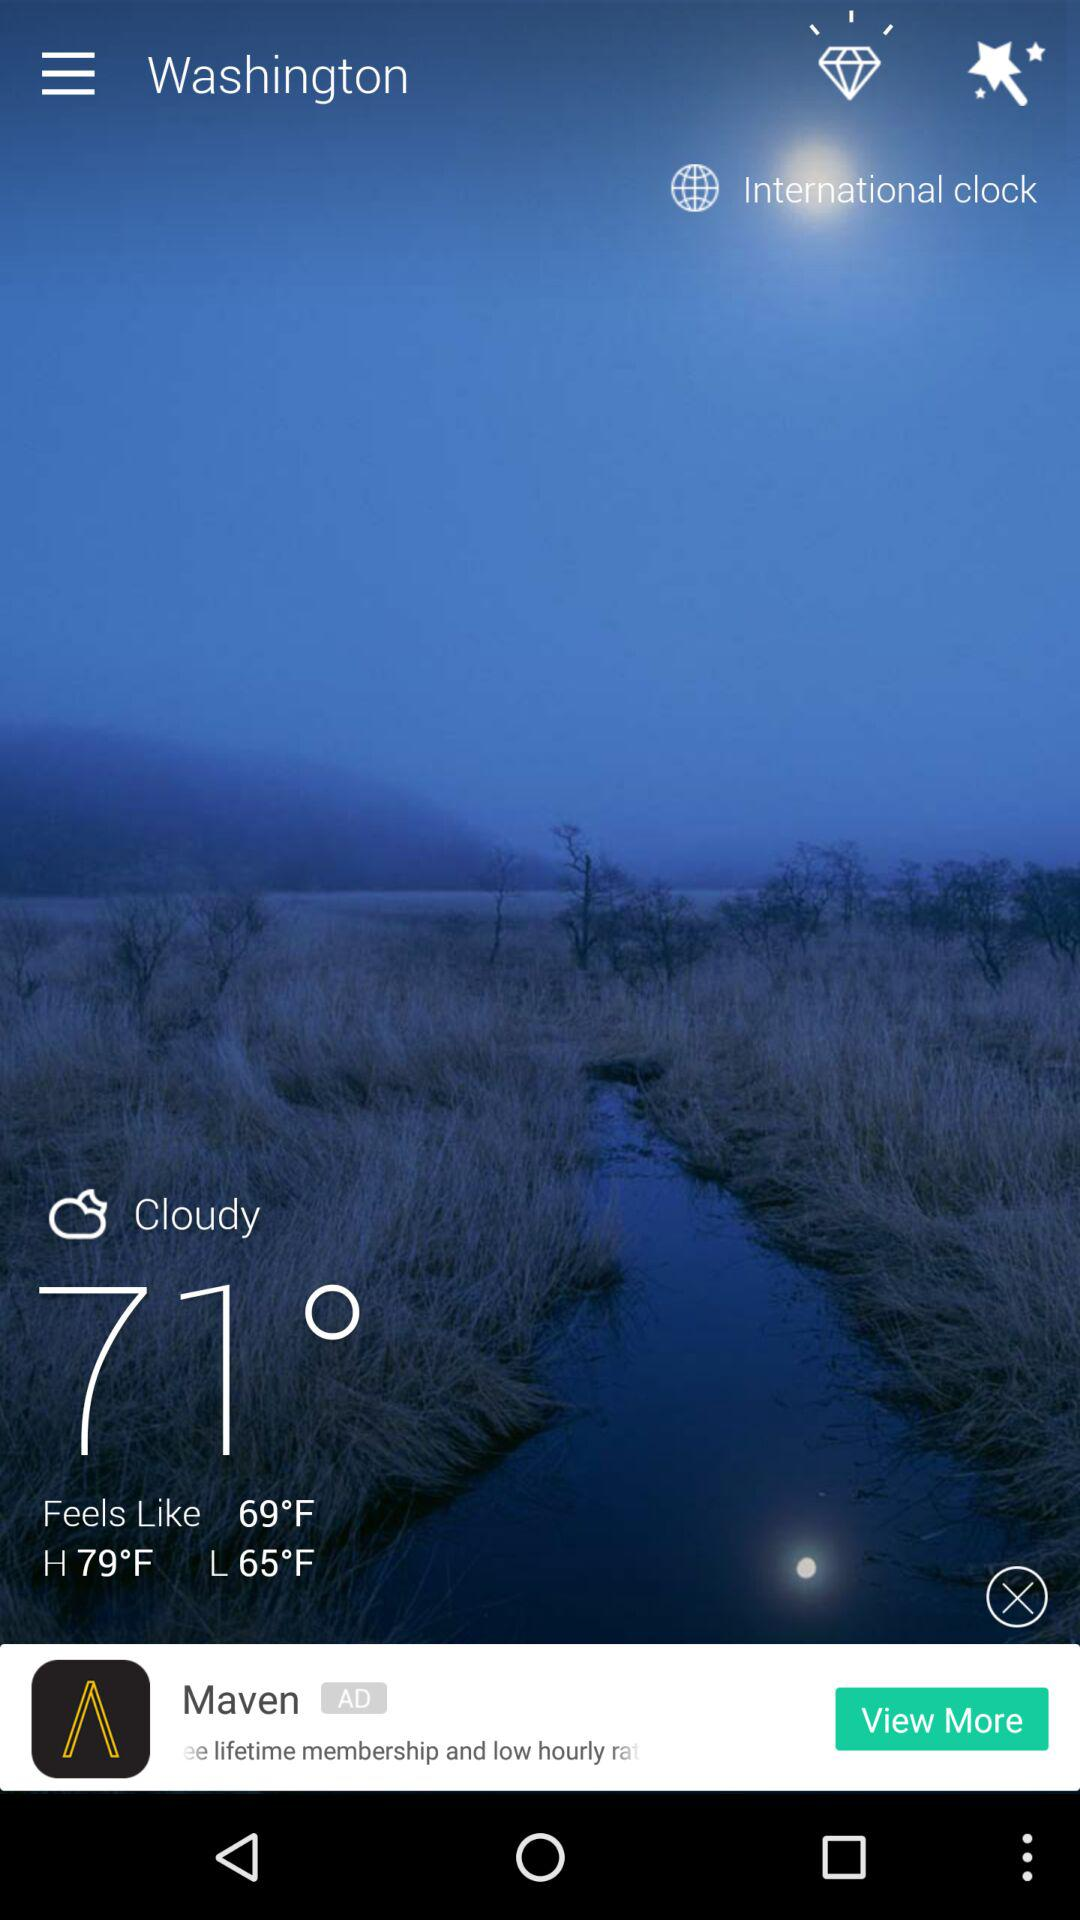How many degrees is the difference between the high and low temperatures?
Answer the question using a single word or phrase. 14 